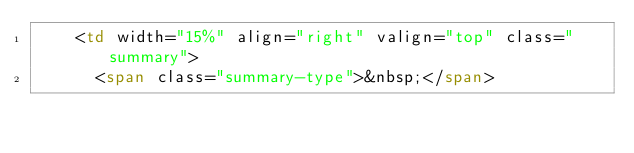<code> <loc_0><loc_0><loc_500><loc_500><_HTML_>    <td width="15%" align="right" valign="top" class="summary">
      <span class="summary-type">&nbsp;</span></code> 